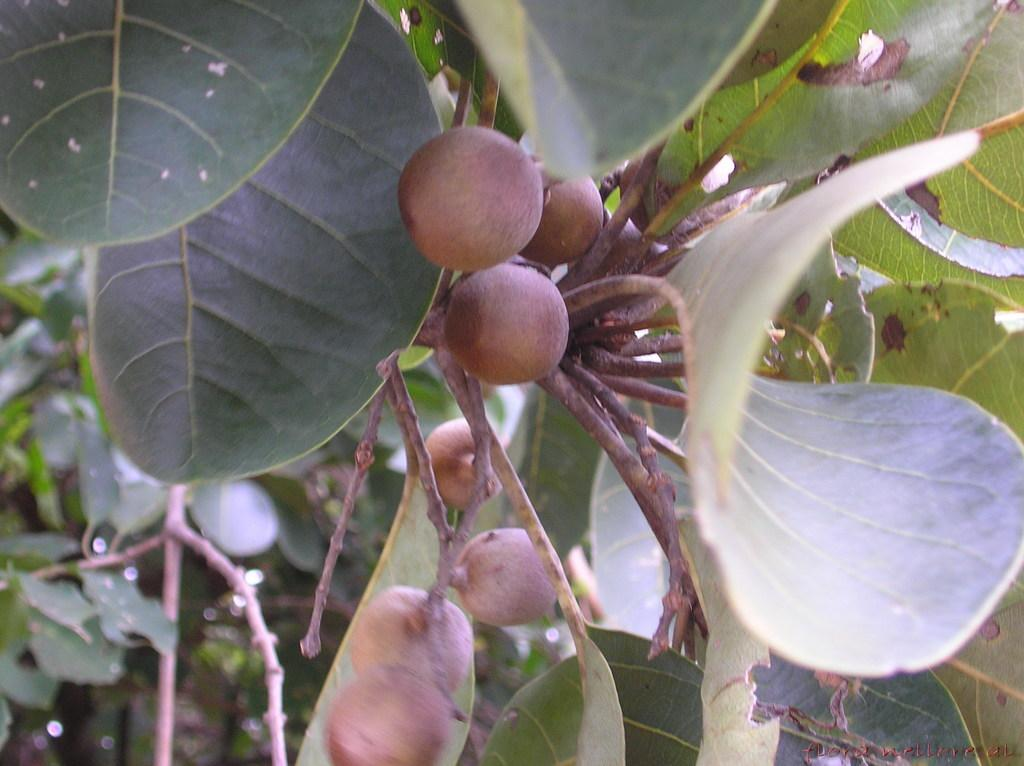What type of living organism is in the image? There is a plant in the image. What are the main features of the plant? The plant has leaves and fruits. What grade does the plant receive for its performance in the image? The image does not depict a grading system or performance evaluation for the plant. 